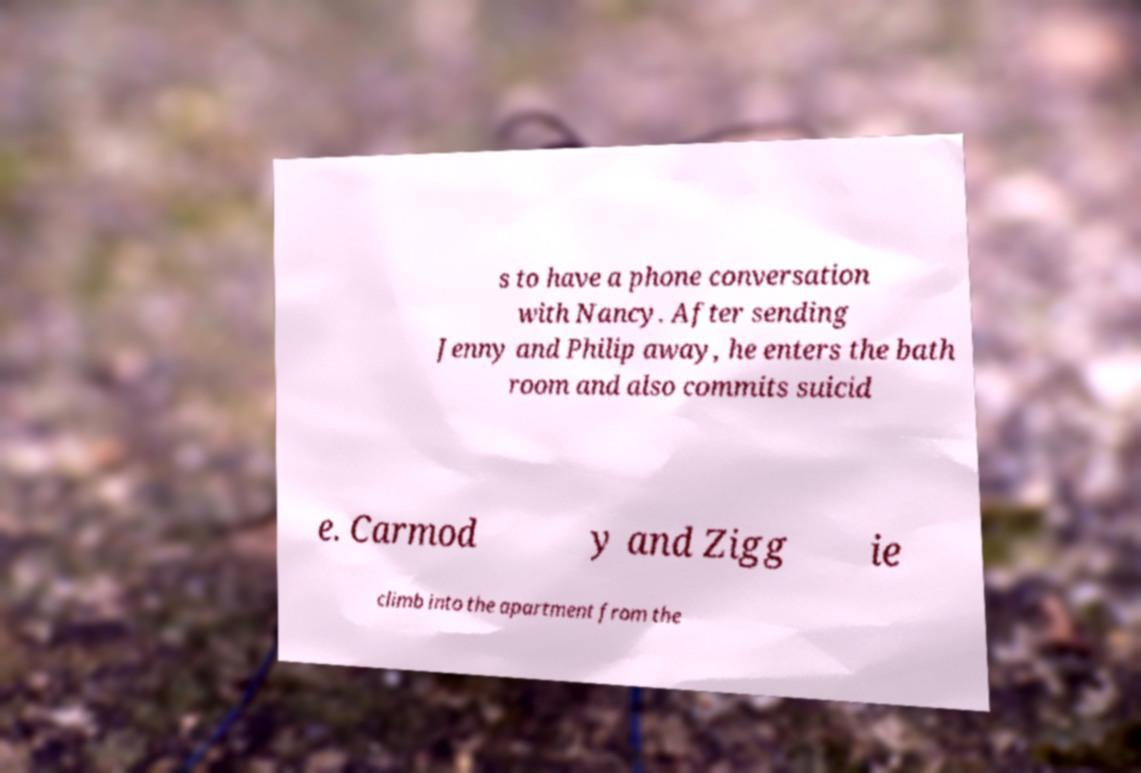There's text embedded in this image that I need extracted. Can you transcribe it verbatim? s to have a phone conversation with Nancy. After sending Jenny and Philip away, he enters the bath room and also commits suicid e. Carmod y and Zigg ie climb into the apartment from the 